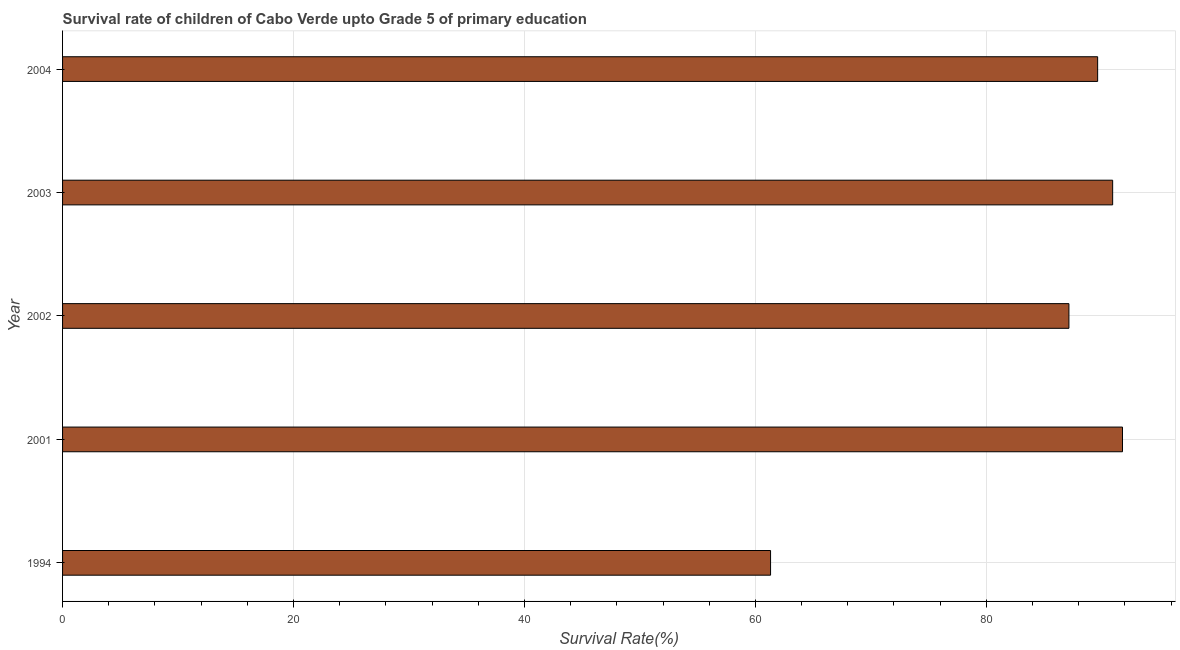Does the graph contain grids?
Keep it short and to the point. Yes. What is the title of the graph?
Offer a terse response. Survival rate of children of Cabo Verde upto Grade 5 of primary education. What is the label or title of the X-axis?
Your answer should be very brief. Survival Rate(%). What is the survival rate in 2002?
Offer a very short reply. 87.15. Across all years, what is the maximum survival rate?
Provide a succinct answer. 91.79. Across all years, what is the minimum survival rate?
Keep it short and to the point. 61.32. In which year was the survival rate maximum?
Offer a terse response. 2001. What is the sum of the survival rate?
Provide a succinct answer. 420.85. What is the difference between the survival rate in 2002 and 2004?
Provide a succinct answer. -2.49. What is the average survival rate per year?
Ensure brevity in your answer.  84.17. What is the median survival rate?
Provide a succinct answer. 89.64. In how many years, is the survival rate greater than 76 %?
Provide a succinct answer. 4. Do a majority of the years between 2002 and 2003 (inclusive) have survival rate greater than 16 %?
Ensure brevity in your answer.  Yes. Is the difference between the survival rate in 2003 and 2004 greater than the difference between any two years?
Ensure brevity in your answer.  No. What is the difference between the highest and the second highest survival rate?
Provide a succinct answer. 0.85. Is the sum of the survival rate in 1994 and 2003 greater than the maximum survival rate across all years?
Give a very brief answer. Yes. What is the difference between the highest and the lowest survival rate?
Provide a succinct answer. 30.48. In how many years, is the survival rate greater than the average survival rate taken over all years?
Offer a terse response. 4. How many years are there in the graph?
Make the answer very short. 5. What is the Survival Rate(%) in 1994?
Your response must be concise. 61.32. What is the Survival Rate(%) in 2001?
Your answer should be very brief. 91.79. What is the Survival Rate(%) in 2002?
Offer a terse response. 87.15. What is the Survival Rate(%) in 2003?
Your response must be concise. 90.94. What is the Survival Rate(%) of 2004?
Your answer should be compact. 89.64. What is the difference between the Survival Rate(%) in 1994 and 2001?
Offer a terse response. -30.48. What is the difference between the Survival Rate(%) in 1994 and 2002?
Offer a very short reply. -25.84. What is the difference between the Survival Rate(%) in 1994 and 2003?
Your answer should be compact. -29.63. What is the difference between the Survival Rate(%) in 1994 and 2004?
Your answer should be very brief. -28.33. What is the difference between the Survival Rate(%) in 2001 and 2002?
Ensure brevity in your answer.  4.64. What is the difference between the Survival Rate(%) in 2001 and 2003?
Offer a terse response. 0.85. What is the difference between the Survival Rate(%) in 2001 and 2004?
Ensure brevity in your answer.  2.15. What is the difference between the Survival Rate(%) in 2002 and 2003?
Offer a very short reply. -3.79. What is the difference between the Survival Rate(%) in 2002 and 2004?
Your response must be concise. -2.49. What is the difference between the Survival Rate(%) in 2003 and 2004?
Ensure brevity in your answer.  1.3. What is the ratio of the Survival Rate(%) in 1994 to that in 2001?
Provide a short and direct response. 0.67. What is the ratio of the Survival Rate(%) in 1994 to that in 2002?
Make the answer very short. 0.7. What is the ratio of the Survival Rate(%) in 1994 to that in 2003?
Your response must be concise. 0.67. What is the ratio of the Survival Rate(%) in 1994 to that in 2004?
Your answer should be compact. 0.68. What is the ratio of the Survival Rate(%) in 2001 to that in 2002?
Provide a short and direct response. 1.05. What is the ratio of the Survival Rate(%) in 2001 to that in 2004?
Give a very brief answer. 1.02. What is the ratio of the Survival Rate(%) in 2002 to that in 2003?
Keep it short and to the point. 0.96. What is the ratio of the Survival Rate(%) in 2002 to that in 2004?
Your answer should be very brief. 0.97. What is the ratio of the Survival Rate(%) in 2003 to that in 2004?
Give a very brief answer. 1.01. 